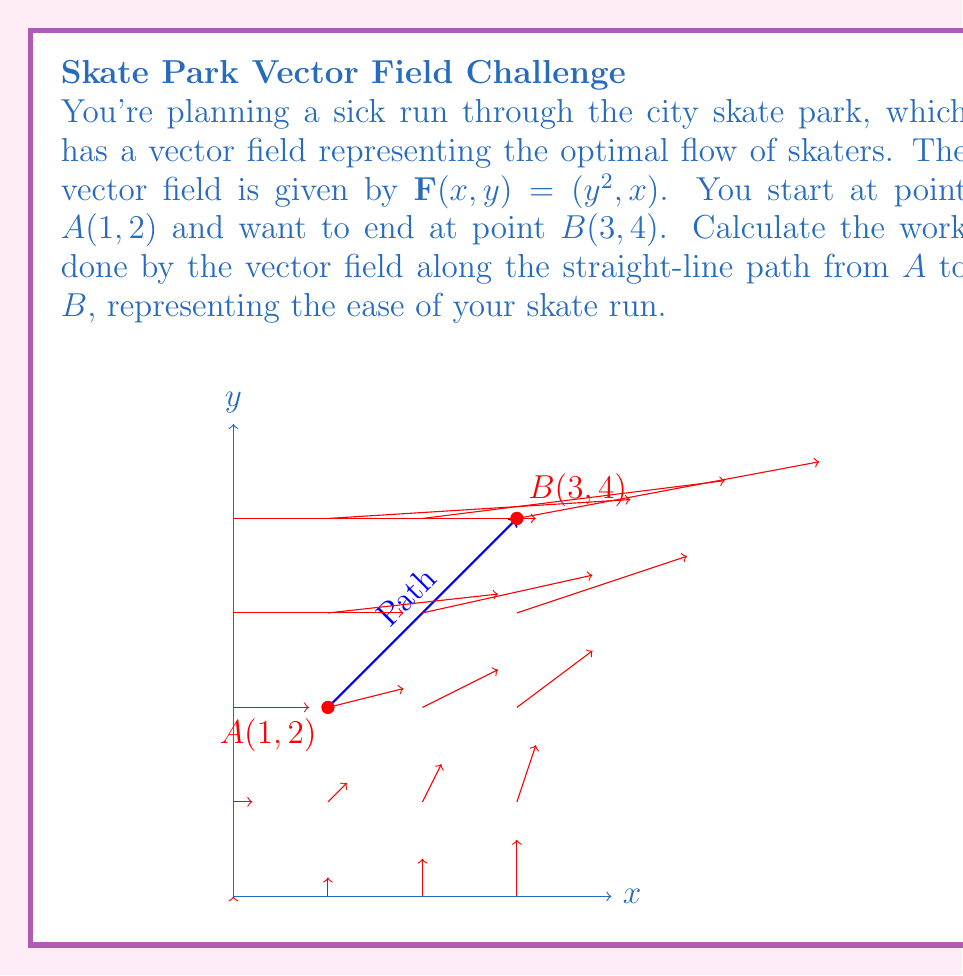Teach me how to tackle this problem. Let's approach this step-by-step:

1) The work done by a vector field $\mathbf{F}(x,y)$ along a path $C$ is given by the line integral:

   $$W = \int_C \mathbf{F} \cdot d\mathbf{r}$$

2) For a straight-line path, we can parameterize the path using:
   
   $x = x_0 + t(x_1 - x_0)$
   $y = y_0 + t(y_1 - y_0)$
   
   where $(x_0, y_0)$ is the start point and $(x_1, y_1)$ is the end point, and $t$ goes from 0 to 1.

3) In our case, $(x_0, y_0) = (1, 2)$ and $(x_1, y_1) = (3, 4)$. So:

   $x = 1 + 2t$
   $y = 2 + 2t$

4) We need to calculate $dx/dt$ and $dy/dt$:

   $dx/dt = 2$
   $dy/dt = 2$

5) Now, we can rewrite our integral:

   $$W = \int_0^1 \mathbf{F}(x(t), y(t)) \cdot (\frac{dx}{dt}, \frac{dy}{dt}) dt$$

6) Substituting our values:

   $$W = \int_0^1 ((2+2t)^2, 1+2t) \cdot (2, 2) dt$$

7) Simplifying:

   $$W = \int_0^1 (2(2+2t)^2 + 2(1+2t)) dt$$
   $$W = \int_0^1 (2(4+8t+4t^2) + 2+4t) dt$$
   $$W = \int_0^1 (8+16t+8t^2 + 2+4t) dt$$
   $$W = \int_0^1 (10+20t+8t^2) dt$$

8) Integrating:

   $$W = [10t + 10t^2 + \frac{8}{3}t^3]_0^1$$

9) Evaluating the bounds:

   $$W = (10 + 10 + \frac{8}{3}) - (0 + 0 + 0)$$
   $$W = 20 + \frac{8}{3} = \frac{68}{3}$$
Answer: $\frac{68}{3}$ 